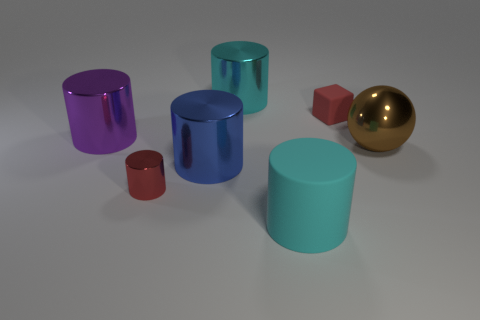What is the shape of the tiny thing that is the same color as the rubber block?
Give a very brief answer. Cylinder. What shape is the purple object that is the same size as the cyan matte cylinder?
Provide a short and direct response. Cylinder. What number of shiny cylinders have the same color as the ball?
Offer a terse response. 0. Is the red object that is in front of the brown metal ball made of the same material as the big brown object?
Provide a succinct answer. Yes. The big purple metallic object is what shape?
Provide a short and direct response. Cylinder. How many brown things are either large shiny things or large rubber things?
Ensure brevity in your answer.  1. What number of other objects are the same material as the tiny cube?
Give a very brief answer. 1. There is a big metallic object that is on the right side of the cyan matte thing; is its shape the same as the small red metallic thing?
Make the answer very short. No. Is there a tiny red cylinder?
Your answer should be compact. Yes. Are there any other things that have the same shape as the big purple thing?
Keep it short and to the point. Yes. 